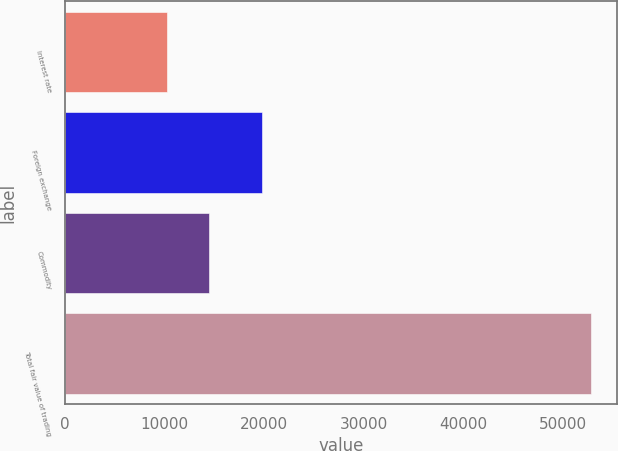<chart> <loc_0><loc_0><loc_500><loc_500><bar_chart><fcel>Interest rate<fcel>Foreign exchange<fcel>Commodity<fcel>Total fair value of trading<nl><fcel>10221<fcel>19769<fcel>14477.9<fcel>52790<nl></chart> 